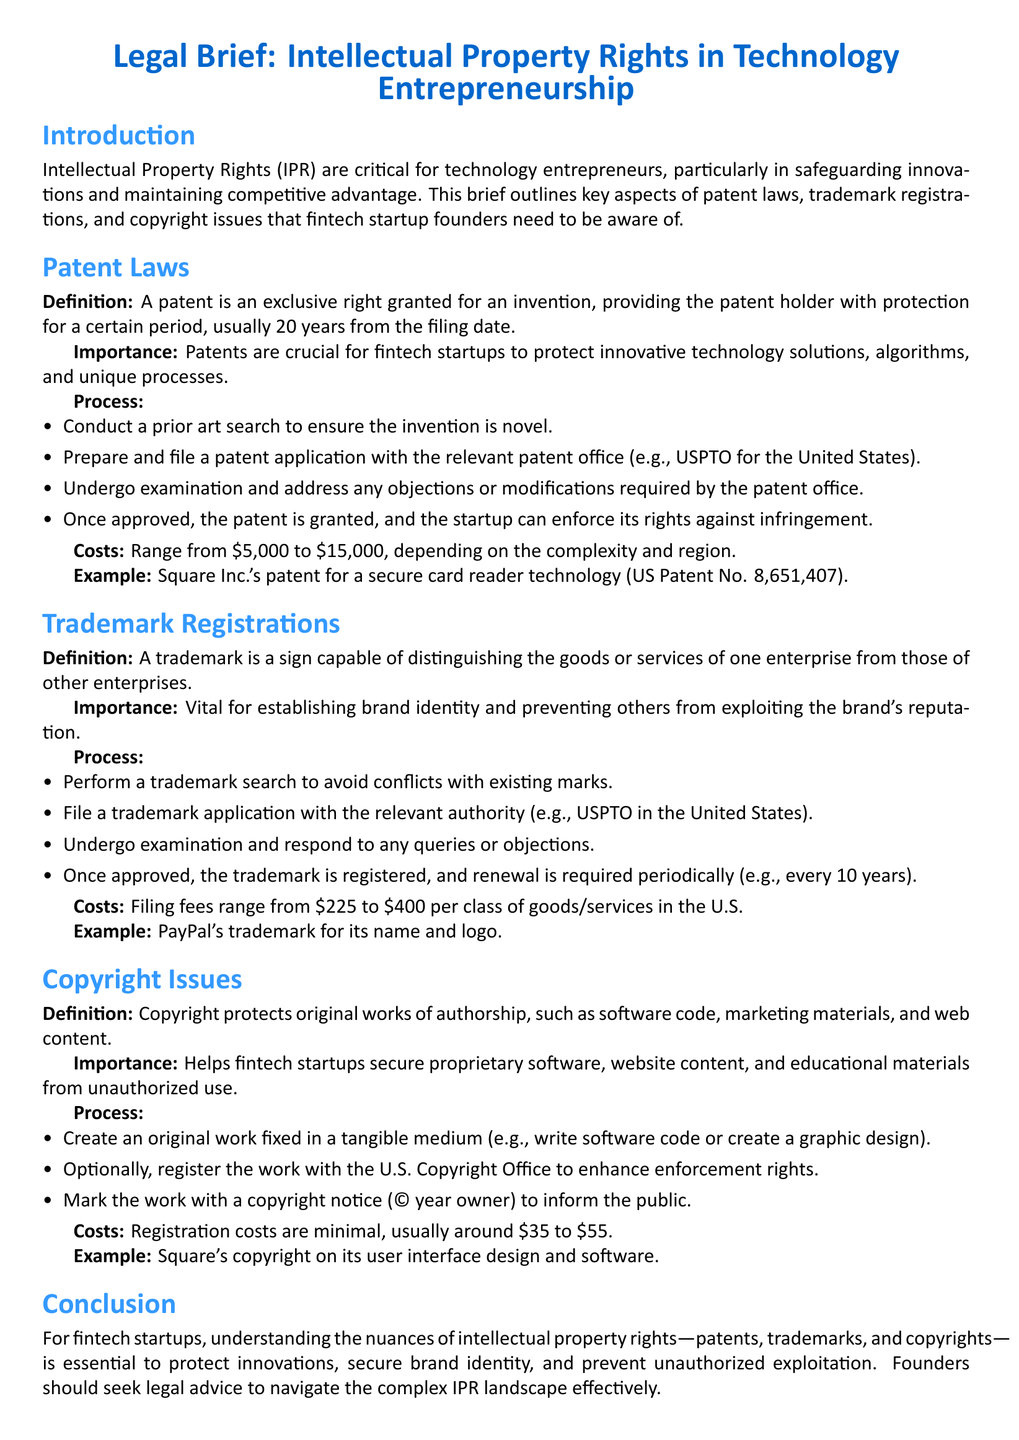What is the exclusive right granted for an invention? A patent is defined as an exclusive right granted for an invention, providing protection for a certain period.
Answer: patent How long is the protection period for a patent? The protection period for a patent is usually 20 years from the filing date.
Answer: 20 years What is the typical filing cost range for a patent? The document states that the costs for filing a patent range from $5,000 to $15,000.
Answer: $5,000 to $15,000 Which trademark authority is mentioned for the United States? The relevant authority for trademark applications in the United States is the USPTO.
Answer: USPTO How much does it typically cost to file a trademark in the U.S.? The filing fees for trademarks in the U.S. range from $225 to $400 per class of goods/services.
Answer: $225 to $400 What is copyright protection intended for? Copyright protects original works of authorship, including software code and web content.
Answer: original works of authorship What are the registration costs for copyright? The document states that registration costs for copyright are usually around $35 to $55.
Answer: $35 to $55 Which fintech company is given as an example for copyright? Square is provided as an example for its copyright on user interface design and software.
Answer: Square What should founders seek to navigate the IPR landscape effectively? Founders should seek legal advice to navigate the complex IPR landscape effectively.
Answer: legal advice 